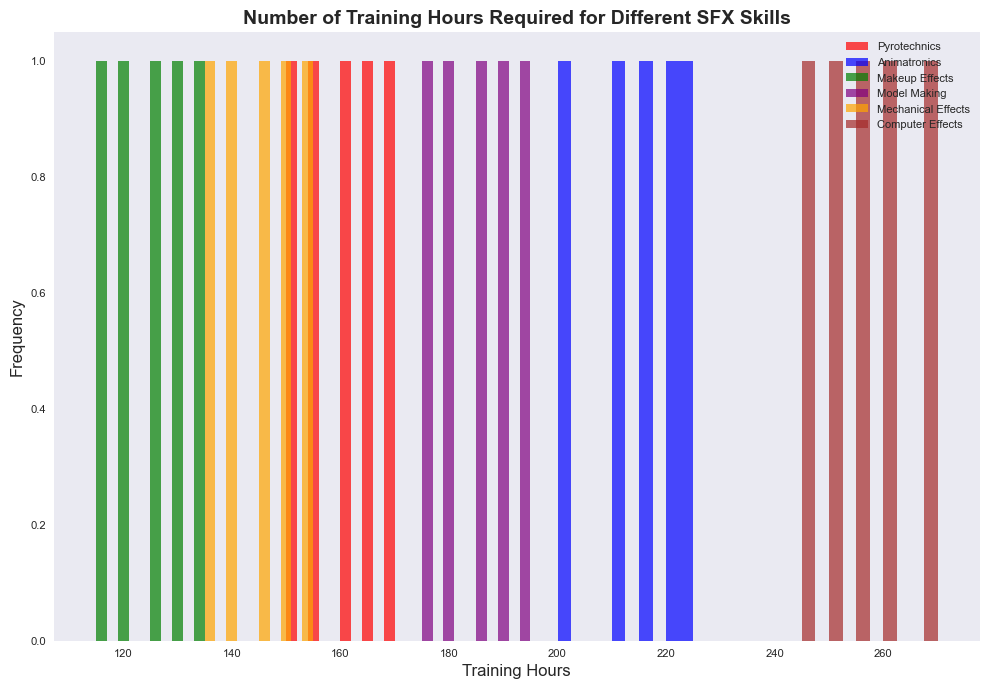Which skill has the highest average number of training hours? To find the skill with the highest average training hours, we first need to calculate the average training hours for each skill. Sum the training hours for each skill and divide by the number of data points for that skill. The skill with the highest result is the answer.
Answer: Computer Effects Which skill has the lowest range of training hours? The range is the difference between the maximum and minimum values of training hours for each skill. The skill with the lowest range will have the smallest difference between its maximum and minimum values.
Answer: Makeup Effects Which skill has the widest spread of training hours? The spread, or range, is the difference between the highest and lowest training hours. To determine this, find the range for each skill and compare them.
Answer: Computer Effects Which bins have the highest frequency in the histogram? Observing the heights of the bars in the histogram, identify which ranges of training hours have the tallest bars. These represent the bins with the highest frequencies.
Answer: Bins around 245-270 hours (Computer Effects) Which skill(s) show overlapping training hour ranges, if any? Check the histogram to see if bars of different colors overlap within the same range of training hours, indicating training hour overlaps between skills.
Answer: No significant overlapping What is the approximate combined frequency of training hours around 150 for Pyrotechnics and Mechanical Effects? Summing the heights of the bars around 150 training hours for Pyrotechnics (red) and Mechanical Effects (orange) will give the total frequency.
Answer: Around 5 In what range do Model Making training hours primarily fall? Observing the histogram for purple bars, identify the range where these bars mostly appear, indicating where most Model Making training hours are concentrated.
Answer: 175-195 hours What is the mean training hours required for Pyrotechnics? Sum the training hours for Pyrotechnics (150, 160, 155, 170, 165) and divide by the number of data points (5).
Answer: 160 Are there any skills whose training hour frequencies are distributed across the entire range without any dominant peaks? A skill with a relatively uniform distribution will not show a single large peak but rather will have smaller, more evenly distributed bars.
Answer: Mechanical Effects Which skill has the second-highest average training hours? Compute the average training hours for all skills. After finding the highest, look for the second highest among the remaining averages.
Answer: Animatronics 